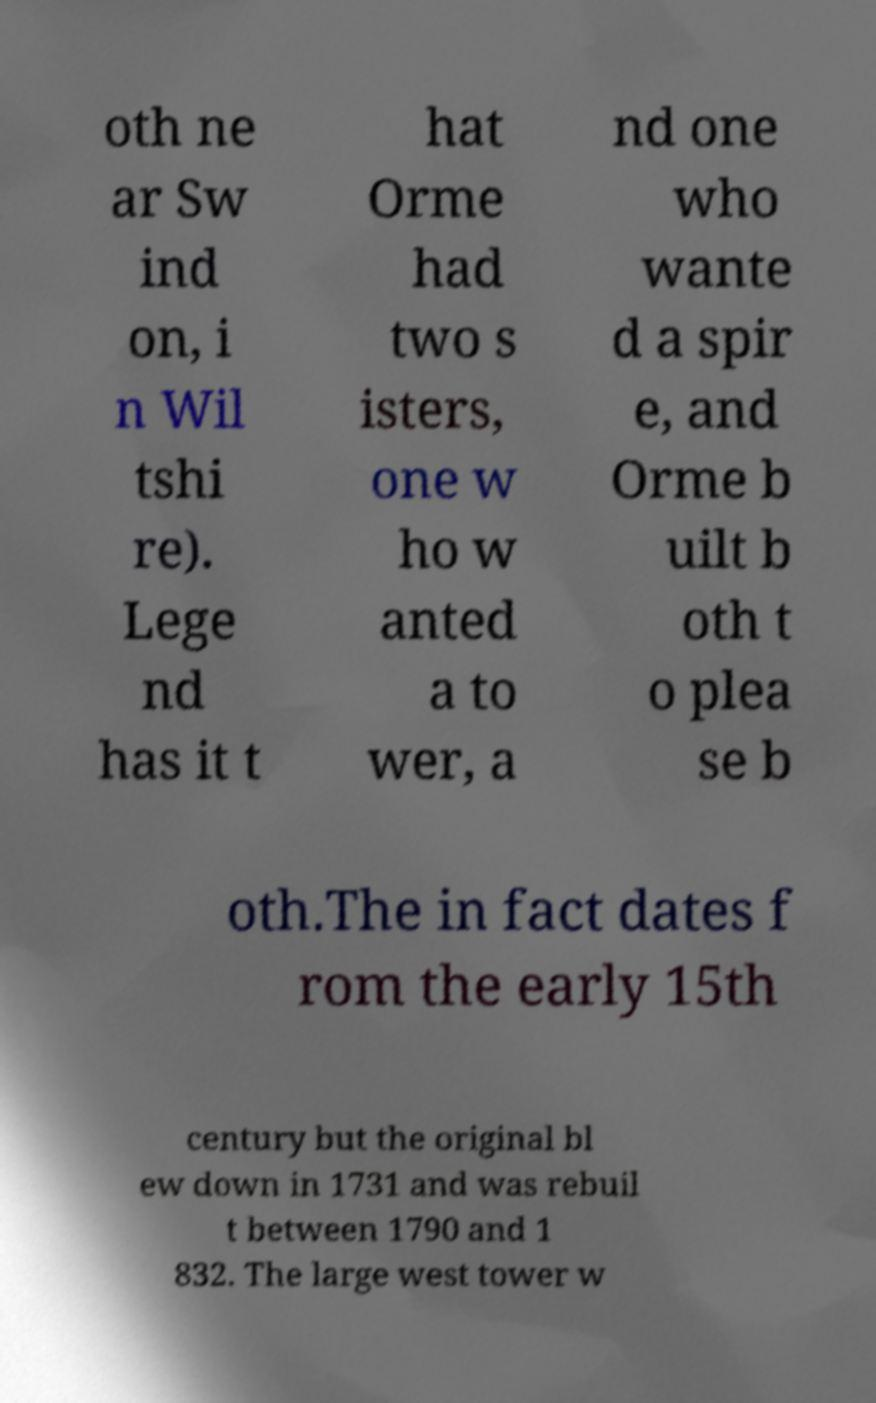I need the written content from this picture converted into text. Can you do that? oth ne ar Sw ind on, i n Wil tshi re). Lege nd has it t hat Orme had two s isters, one w ho w anted a to wer, a nd one who wante d a spir e, and Orme b uilt b oth t o plea se b oth.The in fact dates f rom the early 15th century but the original bl ew down in 1731 and was rebuil t between 1790 and 1 832. The large west tower w 